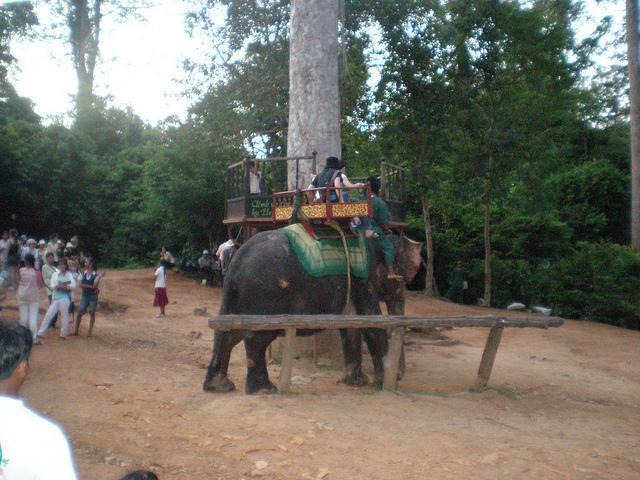What continent is this most likely?
Pick the correct solution from the four options below to address the question.
Options: Europe, asia, antarctica, south america. Asia. 